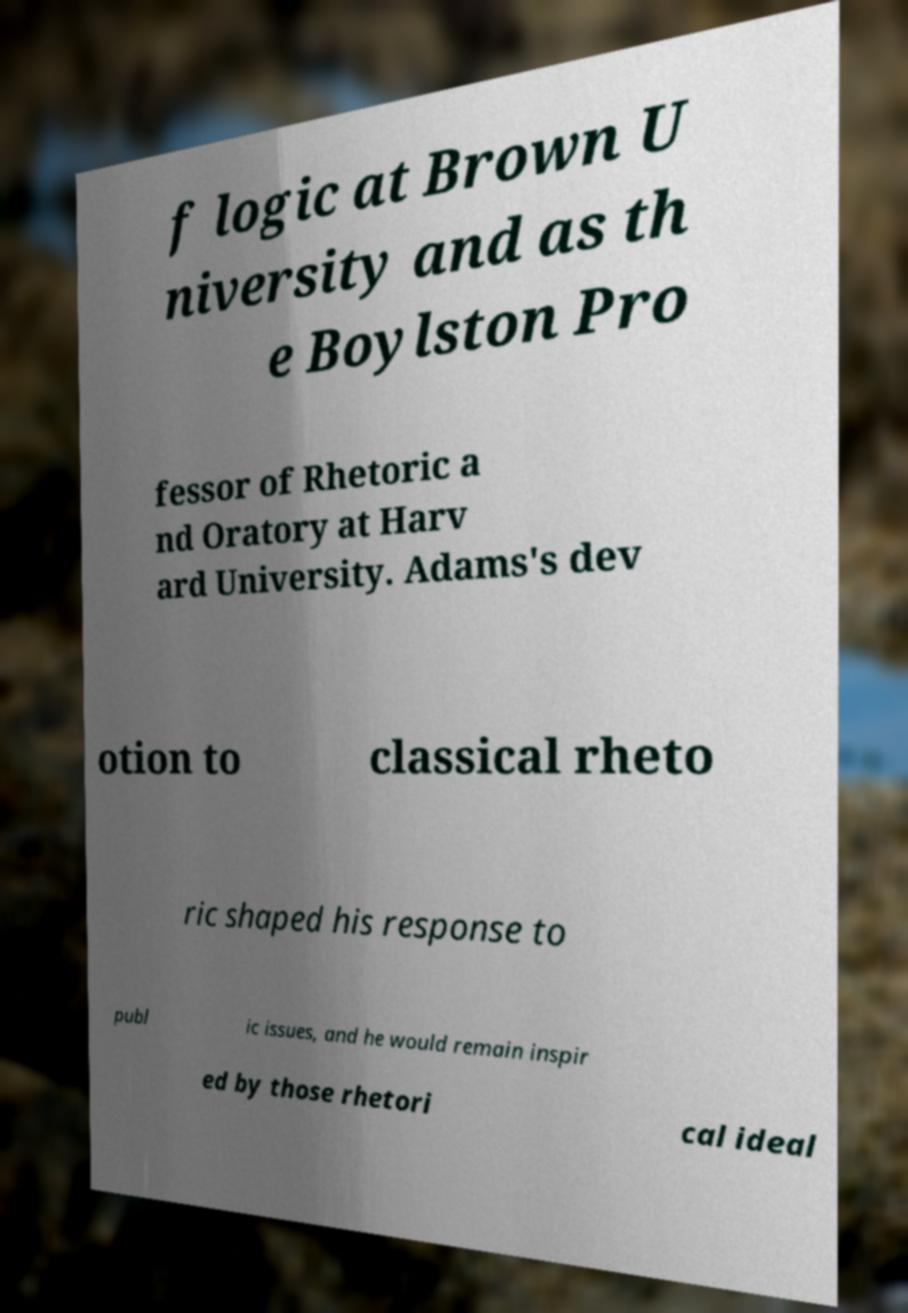What messages or text are displayed in this image? I need them in a readable, typed format. f logic at Brown U niversity and as th e Boylston Pro fessor of Rhetoric a nd Oratory at Harv ard University. Adams's dev otion to classical rheto ric shaped his response to publ ic issues, and he would remain inspir ed by those rhetori cal ideal 